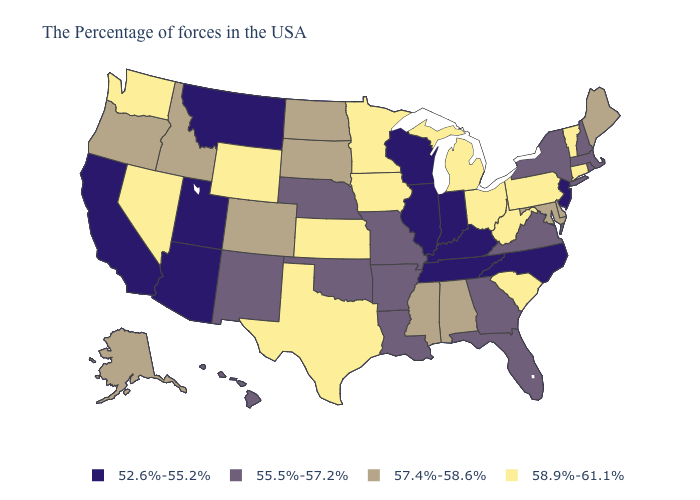Name the states that have a value in the range 57.4%-58.6%?
Give a very brief answer. Maine, Delaware, Maryland, Alabama, Mississippi, South Dakota, North Dakota, Colorado, Idaho, Oregon, Alaska. Which states have the highest value in the USA?
Quick response, please. Vermont, Connecticut, Pennsylvania, South Carolina, West Virginia, Ohio, Michigan, Minnesota, Iowa, Kansas, Texas, Wyoming, Nevada, Washington. What is the value of Wisconsin?
Be succinct. 52.6%-55.2%. Does Missouri have the highest value in the MidWest?
Quick response, please. No. Is the legend a continuous bar?
Be succinct. No. Name the states that have a value in the range 58.9%-61.1%?
Give a very brief answer. Vermont, Connecticut, Pennsylvania, South Carolina, West Virginia, Ohio, Michigan, Minnesota, Iowa, Kansas, Texas, Wyoming, Nevada, Washington. Name the states that have a value in the range 58.9%-61.1%?
Quick response, please. Vermont, Connecticut, Pennsylvania, South Carolina, West Virginia, Ohio, Michigan, Minnesota, Iowa, Kansas, Texas, Wyoming, Nevada, Washington. What is the lowest value in the USA?
Give a very brief answer. 52.6%-55.2%. Among the states that border New Hampshire , which have the highest value?
Answer briefly. Vermont. Name the states that have a value in the range 58.9%-61.1%?
Quick response, please. Vermont, Connecticut, Pennsylvania, South Carolina, West Virginia, Ohio, Michigan, Minnesota, Iowa, Kansas, Texas, Wyoming, Nevada, Washington. Name the states that have a value in the range 55.5%-57.2%?
Write a very short answer. Massachusetts, Rhode Island, New Hampshire, New York, Virginia, Florida, Georgia, Louisiana, Missouri, Arkansas, Nebraska, Oklahoma, New Mexico, Hawaii. Does Minnesota have the highest value in the MidWest?
Concise answer only. Yes. Does Pennsylvania have the lowest value in the USA?
Be succinct. No. Does New Hampshire have a higher value than Texas?
Keep it brief. No. What is the lowest value in the Northeast?
Answer briefly. 52.6%-55.2%. 